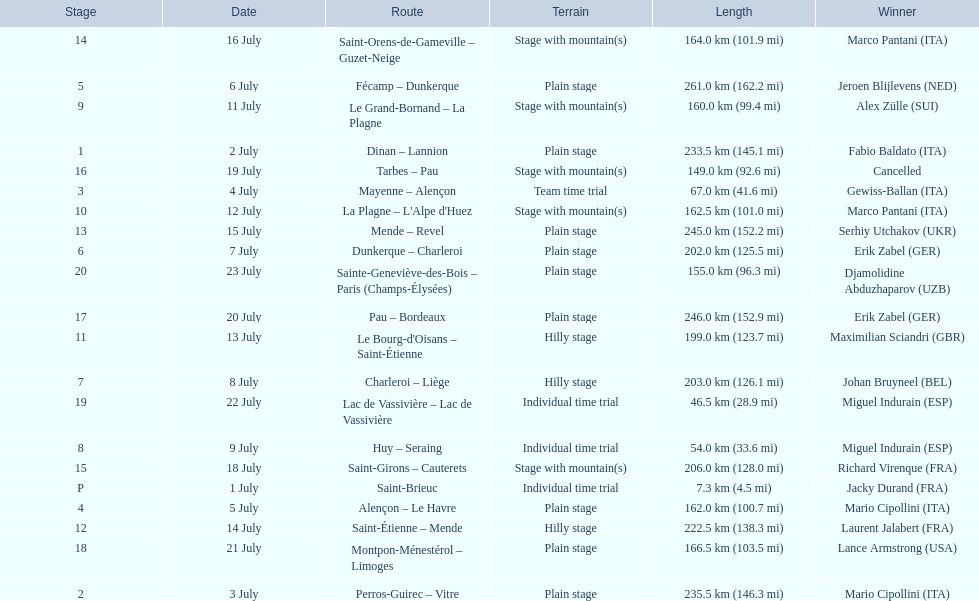What were the dates of the 1995 tour de france? 1 July, 2 July, 3 July, 4 July, 5 July, 6 July, 7 July, 8 July, 9 July, 11 July, 12 July, 13 July, 14 July, 15 July, 16 July, 18 July, 19 July, 20 July, 21 July, 22 July, 23 July. What was the length for july 8th? 203.0 km (126.1 mi). 